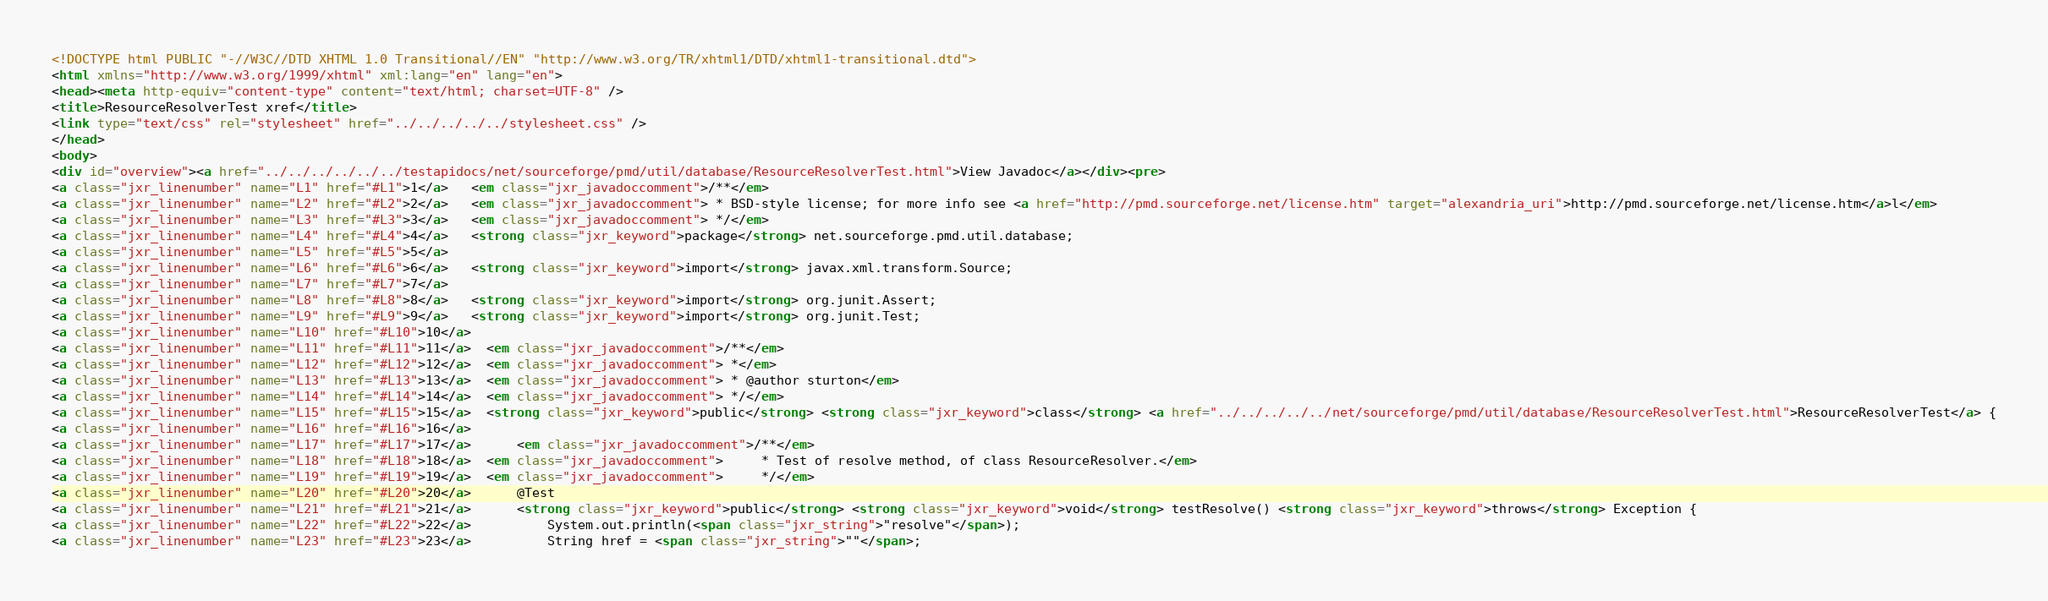Convert code to text. <code><loc_0><loc_0><loc_500><loc_500><_HTML_><!DOCTYPE html PUBLIC "-//W3C//DTD XHTML 1.0 Transitional//EN" "http://www.w3.org/TR/xhtml1/DTD/xhtml1-transitional.dtd">
<html xmlns="http://www.w3.org/1999/xhtml" xml:lang="en" lang="en">
<head><meta http-equiv="content-type" content="text/html; charset=UTF-8" />
<title>ResourceResolverTest xref</title>
<link type="text/css" rel="stylesheet" href="../../../../../stylesheet.css" />
</head>
<body>
<div id="overview"><a href="../../../../../../testapidocs/net/sourceforge/pmd/util/database/ResourceResolverTest.html">View Javadoc</a></div><pre>
<a class="jxr_linenumber" name="L1" href="#L1">1</a>   <em class="jxr_javadoccomment">/**</em>
<a class="jxr_linenumber" name="L2" href="#L2">2</a>   <em class="jxr_javadoccomment"> * BSD-style license; for more info see <a href="http://pmd.sourceforge.net/license.htm" target="alexandria_uri">http://pmd.sourceforge.net/license.htm</a>l</em>
<a class="jxr_linenumber" name="L3" href="#L3">3</a>   <em class="jxr_javadoccomment"> */</em>
<a class="jxr_linenumber" name="L4" href="#L4">4</a>   <strong class="jxr_keyword">package</strong> net.sourceforge.pmd.util.database;
<a class="jxr_linenumber" name="L5" href="#L5">5</a>   
<a class="jxr_linenumber" name="L6" href="#L6">6</a>   <strong class="jxr_keyword">import</strong> javax.xml.transform.Source;
<a class="jxr_linenumber" name="L7" href="#L7">7</a>   
<a class="jxr_linenumber" name="L8" href="#L8">8</a>   <strong class="jxr_keyword">import</strong> org.junit.Assert;
<a class="jxr_linenumber" name="L9" href="#L9">9</a>   <strong class="jxr_keyword">import</strong> org.junit.Test;
<a class="jxr_linenumber" name="L10" href="#L10">10</a>  
<a class="jxr_linenumber" name="L11" href="#L11">11</a>  <em class="jxr_javadoccomment">/**</em>
<a class="jxr_linenumber" name="L12" href="#L12">12</a>  <em class="jxr_javadoccomment"> *</em>
<a class="jxr_linenumber" name="L13" href="#L13">13</a>  <em class="jxr_javadoccomment"> * @author sturton</em>
<a class="jxr_linenumber" name="L14" href="#L14">14</a>  <em class="jxr_javadoccomment"> */</em>
<a class="jxr_linenumber" name="L15" href="#L15">15</a>  <strong class="jxr_keyword">public</strong> <strong class="jxr_keyword">class</strong> <a href="../../../../../net/sourceforge/pmd/util/database/ResourceResolverTest.html">ResourceResolverTest</a> {
<a class="jxr_linenumber" name="L16" href="#L16">16</a>  
<a class="jxr_linenumber" name="L17" href="#L17">17</a>      <em class="jxr_javadoccomment">/**</em>
<a class="jxr_linenumber" name="L18" href="#L18">18</a>  <em class="jxr_javadoccomment">     * Test of resolve method, of class ResourceResolver.</em>
<a class="jxr_linenumber" name="L19" href="#L19">19</a>  <em class="jxr_javadoccomment">     */</em>
<a class="jxr_linenumber" name="L20" href="#L20">20</a>      @Test
<a class="jxr_linenumber" name="L21" href="#L21">21</a>      <strong class="jxr_keyword">public</strong> <strong class="jxr_keyword">void</strong> testResolve() <strong class="jxr_keyword">throws</strong> Exception {
<a class="jxr_linenumber" name="L22" href="#L22">22</a>          System.out.println(<span class="jxr_string">"resolve"</span>);
<a class="jxr_linenumber" name="L23" href="#L23">23</a>          String href = <span class="jxr_string">""</span>;</code> 